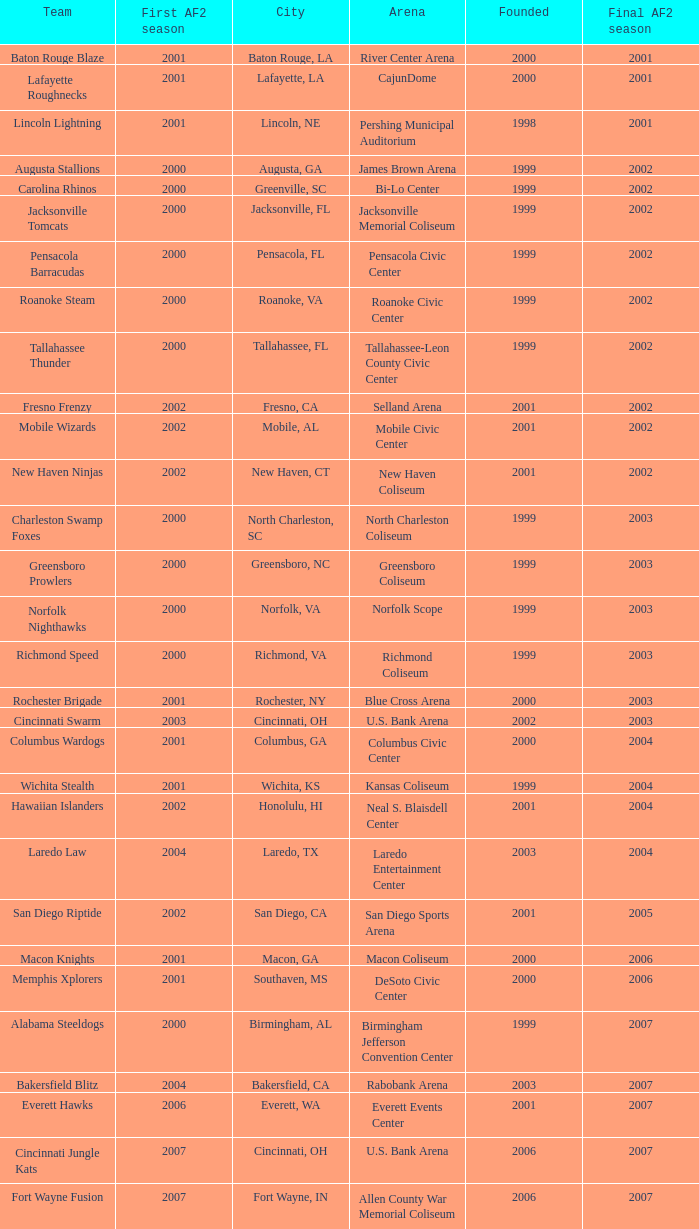Parse the full table. {'header': ['Team', 'First AF2 season', 'City', 'Arena', 'Founded', 'Final AF2 season'], 'rows': [['Baton Rouge Blaze', '2001', 'Baton Rouge, LA', 'River Center Arena', '2000', '2001'], ['Lafayette Roughnecks', '2001', 'Lafayette, LA', 'CajunDome', '2000', '2001'], ['Lincoln Lightning', '2001', 'Lincoln, NE', 'Pershing Municipal Auditorium', '1998', '2001'], ['Augusta Stallions', '2000', 'Augusta, GA', 'James Brown Arena', '1999', '2002'], ['Carolina Rhinos', '2000', 'Greenville, SC', 'Bi-Lo Center', '1999', '2002'], ['Jacksonville Tomcats', '2000', 'Jacksonville, FL', 'Jacksonville Memorial Coliseum', '1999', '2002'], ['Pensacola Barracudas', '2000', 'Pensacola, FL', 'Pensacola Civic Center', '1999', '2002'], ['Roanoke Steam', '2000', 'Roanoke, VA', 'Roanoke Civic Center', '1999', '2002'], ['Tallahassee Thunder', '2000', 'Tallahassee, FL', 'Tallahassee-Leon County Civic Center', '1999', '2002'], ['Fresno Frenzy', '2002', 'Fresno, CA', 'Selland Arena', '2001', '2002'], ['Mobile Wizards', '2002', 'Mobile, AL', 'Mobile Civic Center', '2001', '2002'], ['New Haven Ninjas', '2002', 'New Haven, CT', 'New Haven Coliseum', '2001', '2002'], ['Charleston Swamp Foxes', '2000', 'North Charleston, SC', 'North Charleston Coliseum', '1999', '2003'], ['Greensboro Prowlers', '2000', 'Greensboro, NC', 'Greensboro Coliseum', '1999', '2003'], ['Norfolk Nighthawks', '2000', 'Norfolk, VA', 'Norfolk Scope', '1999', '2003'], ['Richmond Speed', '2000', 'Richmond, VA', 'Richmond Coliseum', '1999', '2003'], ['Rochester Brigade', '2001', 'Rochester, NY', 'Blue Cross Arena', '2000', '2003'], ['Cincinnati Swarm', '2003', 'Cincinnati, OH', 'U.S. Bank Arena', '2002', '2003'], ['Columbus Wardogs', '2001', 'Columbus, GA', 'Columbus Civic Center', '2000', '2004'], ['Wichita Stealth', '2001', 'Wichita, KS', 'Kansas Coliseum', '1999', '2004'], ['Hawaiian Islanders', '2002', 'Honolulu, HI', 'Neal S. Blaisdell Center', '2001', '2004'], ['Laredo Law', '2004', 'Laredo, TX', 'Laredo Entertainment Center', '2003', '2004'], ['San Diego Riptide', '2002', 'San Diego, CA', 'San Diego Sports Arena', '2001', '2005'], ['Macon Knights', '2001', 'Macon, GA', 'Macon Coliseum', '2000', '2006'], ['Memphis Xplorers', '2001', 'Southaven, MS', 'DeSoto Civic Center', '2000', '2006'], ['Alabama Steeldogs', '2000', 'Birmingham, AL', 'Birmingham Jefferson Convention Center', '1999', '2007'], ['Bakersfield Blitz', '2004', 'Bakersfield, CA', 'Rabobank Arena', '2003', '2007'], ['Everett Hawks', '2006', 'Everett, WA', 'Everett Events Center', '2001', '2007'], ['Cincinnati Jungle Kats', '2007', 'Cincinnati, OH', 'U.S. Bank Arena', '2006', '2007'], ['Fort Wayne Fusion', '2007', 'Fort Wayne, IN', 'Allen County War Memorial Coliseum', '2006', '2007'], ['Laredo Lobos', '2007', 'Laredo, TX', 'Laredo Entertainment Center', '2005', '2007'], ['Louisville Fire', '2001', 'Louisville, KY', 'Freedom Hall', '2000', '2008'], ['Lubbock Renegades', '2007', 'Lubbock, TX', 'City Bank Coliseum', '2006', '2008'], ['Texas Copperheads', '2007', 'Cypress, TX', 'Richard E. Berry Educational Support Center', '2005', '2008'], ['Austin Wranglers', '2008', 'Austin, TX', 'Frank Erwin Center', '2003', '2008'], ['Daytona Beach ThunderBirds', '2008', 'Daytona Beach, FL', 'Ocean Center', '2005', '2008'], ['Mahoning Valley Thunder', '2007', 'Youngstown, OH', 'Covelli Centre', '2007', '2009'], ['Arkansas Twisters', '2000', 'North Little Rock, Arkansas', 'Verizon Arena', '1999', '2009'], ['Central Valley Coyotes', '2002', 'Fresno, California', 'Selland Arena', '2001', '2009'], ['Kentucky Horsemen', '2008', 'Lexington, Kentucky', 'Rupp Arena', '2002', '2009'], ['Tri-Cities Fever', '2007', 'Kennewick, Washington', 'Toyota Center', '2004', '2009']]} What is the mean Founded number when the team is the Baton Rouge Blaze? 2000.0. 